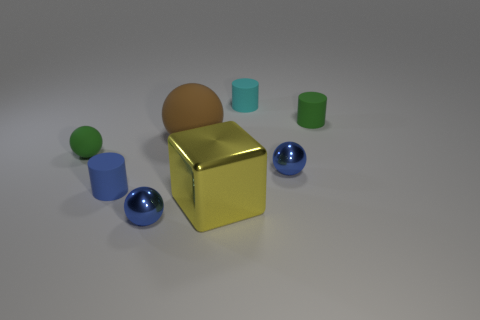Add 1 gray shiny balls. How many objects exist? 9 Subtract all blocks. How many objects are left? 7 Subtract 1 yellow blocks. How many objects are left? 7 Subtract all big purple metallic things. Subtract all cyan things. How many objects are left? 7 Add 2 blue objects. How many blue objects are left? 5 Add 8 small green matte spheres. How many small green matte spheres exist? 9 